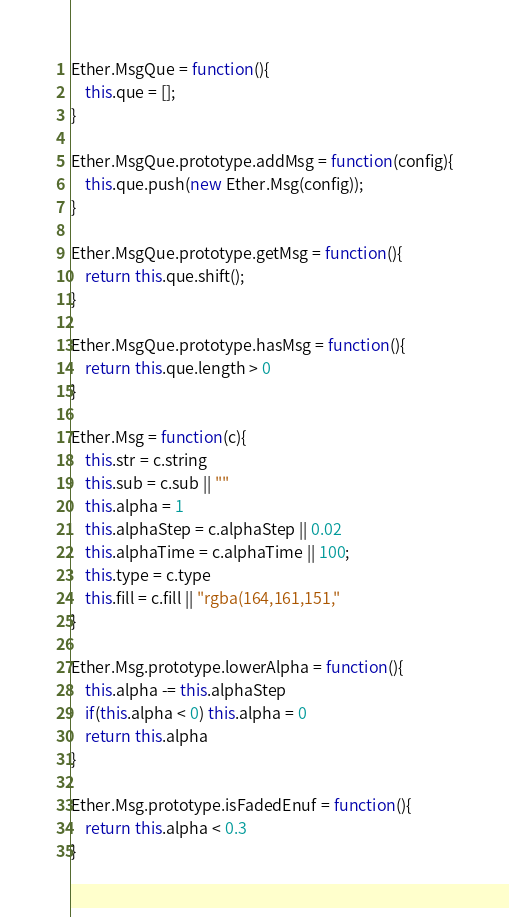Convert code to text. <code><loc_0><loc_0><loc_500><loc_500><_JavaScript_>Ether.MsgQue = function(){
	this.que = [];
}

Ether.MsgQue.prototype.addMsg = function(config){
	this.que.push(new Ether.Msg(config));
}

Ether.MsgQue.prototype.getMsg = function(){
	return this.que.shift();
}

Ether.MsgQue.prototype.hasMsg = function(){
	return this.que.length > 0
}

Ether.Msg = function(c){
	this.str = c.string
	this.sub = c.sub || ""
	this.alpha = 1
	this.alphaStep = c.alphaStep || 0.02
	this.alphaTime = c.alphaTime || 100;
	this.type = c.type
	this.fill = c.fill || "rgba(164,161,151,"
}

Ether.Msg.prototype.lowerAlpha = function(){
	this.alpha -= this.alphaStep
	if(this.alpha < 0) this.alpha = 0
	return this.alpha
}

Ether.Msg.prototype.isFadedEnuf = function(){
	return this.alpha < 0.3
}</code> 